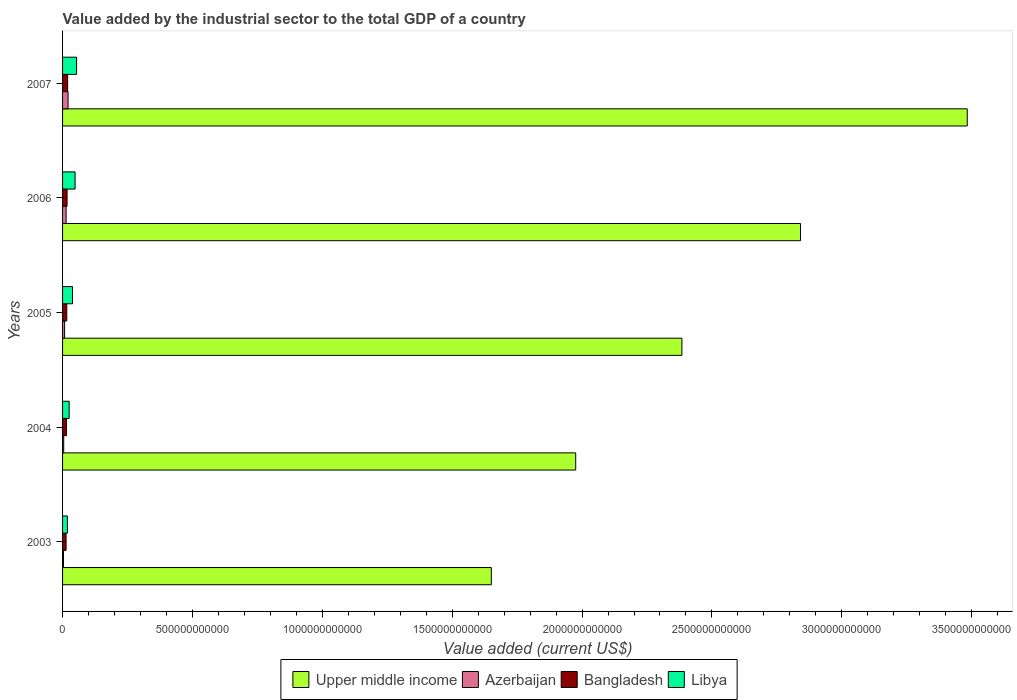How many different coloured bars are there?
Provide a succinct answer. 4. How many groups of bars are there?
Your answer should be very brief. 5. Are the number of bars per tick equal to the number of legend labels?
Offer a terse response. Yes. Are the number of bars on each tick of the Y-axis equal?
Offer a terse response. Yes. How many bars are there on the 2nd tick from the bottom?
Offer a very short reply. 4. In how many cases, is the number of bars for a given year not equal to the number of legend labels?
Your response must be concise. 0. What is the value added by the industrial sector to the total GDP in Azerbaijan in 2004?
Provide a short and direct response. 4.41e+09. Across all years, what is the maximum value added by the industrial sector to the total GDP in Libya?
Your answer should be compact. 5.40e+1. Across all years, what is the minimum value added by the industrial sector to the total GDP in Azerbaijan?
Keep it short and to the point. 3.53e+09. What is the total value added by the industrial sector to the total GDP in Bangladesh in the graph?
Provide a short and direct response. 8.13e+1. What is the difference between the value added by the industrial sector to the total GDP in Libya in 2005 and that in 2007?
Ensure brevity in your answer.  -1.57e+1. What is the difference between the value added by the industrial sector to the total GDP in Bangladesh in 2004 and the value added by the industrial sector to the total GDP in Libya in 2007?
Offer a terse response. -3.92e+1. What is the average value added by the industrial sector to the total GDP in Libya per year?
Give a very brief answer. 3.69e+1. In the year 2003, what is the difference between the value added by the industrial sector to the total GDP in Azerbaijan and value added by the industrial sector to the total GDP in Bangladesh?
Give a very brief answer. -9.99e+09. What is the ratio of the value added by the industrial sector to the total GDP in Upper middle income in 2003 to that in 2005?
Your response must be concise. 0.69. Is the value added by the industrial sector to the total GDP in Upper middle income in 2004 less than that in 2006?
Keep it short and to the point. Yes. What is the difference between the highest and the second highest value added by the industrial sector to the total GDP in Azerbaijan?
Offer a very short reply. 7.51e+09. What is the difference between the highest and the lowest value added by the industrial sector to the total GDP in Azerbaijan?
Provide a short and direct response. 1.76e+1. Is it the case that in every year, the sum of the value added by the industrial sector to the total GDP in Libya and value added by the industrial sector to the total GDP in Bangladesh is greater than the sum of value added by the industrial sector to the total GDP in Azerbaijan and value added by the industrial sector to the total GDP in Upper middle income?
Give a very brief answer. No. What does the 1st bar from the bottom in 2006 represents?
Provide a short and direct response. Upper middle income. Is it the case that in every year, the sum of the value added by the industrial sector to the total GDP in Libya and value added by the industrial sector to the total GDP in Upper middle income is greater than the value added by the industrial sector to the total GDP in Azerbaijan?
Ensure brevity in your answer.  Yes. How many bars are there?
Give a very brief answer. 20. Are all the bars in the graph horizontal?
Ensure brevity in your answer.  Yes. How many years are there in the graph?
Provide a short and direct response. 5. What is the difference between two consecutive major ticks on the X-axis?
Make the answer very short. 5.00e+11. Are the values on the major ticks of X-axis written in scientific E-notation?
Ensure brevity in your answer.  No. Does the graph contain any zero values?
Offer a very short reply. No. Does the graph contain grids?
Give a very brief answer. No. Where does the legend appear in the graph?
Your answer should be very brief. Bottom center. What is the title of the graph?
Provide a short and direct response. Value added by the industrial sector to the total GDP of a country. What is the label or title of the X-axis?
Ensure brevity in your answer.  Value added (current US$). What is the Value added (current US$) in Upper middle income in 2003?
Offer a very short reply. 1.65e+12. What is the Value added (current US$) of Azerbaijan in 2003?
Make the answer very short. 3.53e+09. What is the Value added (current US$) of Bangladesh in 2003?
Keep it short and to the point. 1.35e+1. What is the Value added (current US$) in Libya in 2003?
Provide a succinct answer. 1.86e+1. What is the Value added (current US$) of Upper middle income in 2004?
Provide a short and direct response. 1.98e+12. What is the Value added (current US$) in Azerbaijan in 2004?
Your answer should be compact. 4.41e+09. What is the Value added (current US$) in Bangladesh in 2004?
Provide a short and direct response. 1.48e+1. What is the Value added (current US$) in Libya in 2004?
Offer a very short reply. 2.54e+1. What is the Value added (current US$) in Upper middle income in 2005?
Make the answer very short. 2.38e+12. What is the Value added (current US$) in Azerbaijan in 2005?
Your answer should be compact. 7.79e+09. What is the Value added (current US$) of Bangladesh in 2005?
Offer a very short reply. 1.62e+1. What is the Value added (current US$) of Libya in 2005?
Offer a terse response. 3.83e+1. What is the Value added (current US$) of Upper middle income in 2006?
Offer a terse response. 2.84e+12. What is the Value added (current US$) of Azerbaijan in 2006?
Keep it short and to the point. 1.36e+1. What is the Value added (current US$) of Bangladesh in 2006?
Your answer should be compact. 1.73e+1. What is the Value added (current US$) of Libya in 2006?
Your answer should be very brief. 4.83e+1. What is the Value added (current US$) of Upper middle income in 2007?
Keep it short and to the point. 3.48e+12. What is the Value added (current US$) in Azerbaijan in 2007?
Make the answer very short. 2.11e+1. What is the Value added (current US$) in Bangladesh in 2007?
Your answer should be very brief. 1.95e+1. What is the Value added (current US$) of Libya in 2007?
Your answer should be very brief. 5.40e+1. Across all years, what is the maximum Value added (current US$) of Upper middle income?
Offer a terse response. 3.48e+12. Across all years, what is the maximum Value added (current US$) in Azerbaijan?
Offer a very short reply. 2.11e+1. Across all years, what is the maximum Value added (current US$) in Bangladesh?
Your answer should be very brief. 1.95e+1. Across all years, what is the maximum Value added (current US$) of Libya?
Make the answer very short. 5.40e+1. Across all years, what is the minimum Value added (current US$) of Upper middle income?
Offer a very short reply. 1.65e+12. Across all years, what is the minimum Value added (current US$) of Azerbaijan?
Ensure brevity in your answer.  3.53e+09. Across all years, what is the minimum Value added (current US$) of Bangladesh?
Your response must be concise. 1.35e+1. Across all years, what is the minimum Value added (current US$) of Libya?
Your response must be concise. 1.86e+1. What is the total Value added (current US$) in Upper middle income in the graph?
Provide a succinct answer. 1.23e+13. What is the total Value added (current US$) of Azerbaijan in the graph?
Your answer should be very brief. 5.05e+1. What is the total Value added (current US$) of Bangladesh in the graph?
Give a very brief answer. 8.13e+1. What is the total Value added (current US$) of Libya in the graph?
Make the answer very short. 1.85e+11. What is the difference between the Value added (current US$) in Upper middle income in 2003 and that in 2004?
Your response must be concise. -3.25e+11. What is the difference between the Value added (current US$) of Azerbaijan in 2003 and that in 2004?
Make the answer very short. -8.75e+08. What is the difference between the Value added (current US$) of Bangladesh in 2003 and that in 2004?
Ensure brevity in your answer.  -1.31e+09. What is the difference between the Value added (current US$) in Libya in 2003 and that in 2004?
Offer a terse response. -6.77e+09. What is the difference between the Value added (current US$) of Upper middle income in 2003 and that in 2005?
Your answer should be very brief. -7.34e+11. What is the difference between the Value added (current US$) of Azerbaijan in 2003 and that in 2005?
Keep it short and to the point. -4.26e+09. What is the difference between the Value added (current US$) in Bangladesh in 2003 and that in 2005?
Make the answer very short. -2.66e+09. What is the difference between the Value added (current US$) of Libya in 2003 and that in 2005?
Make the answer very short. -1.97e+1. What is the difference between the Value added (current US$) of Upper middle income in 2003 and that in 2006?
Your answer should be compact. -1.19e+12. What is the difference between the Value added (current US$) of Azerbaijan in 2003 and that in 2006?
Offer a very short reply. -1.01e+1. What is the difference between the Value added (current US$) of Bangladesh in 2003 and that in 2006?
Provide a short and direct response. -3.78e+09. What is the difference between the Value added (current US$) of Libya in 2003 and that in 2006?
Your response must be concise. -2.96e+1. What is the difference between the Value added (current US$) of Upper middle income in 2003 and that in 2007?
Offer a very short reply. -1.83e+12. What is the difference between the Value added (current US$) in Azerbaijan in 2003 and that in 2007?
Give a very brief answer. -1.76e+1. What is the difference between the Value added (current US$) in Bangladesh in 2003 and that in 2007?
Provide a succinct answer. -5.99e+09. What is the difference between the Value added (current US$) in Libya in 2003 and that in 2007?
Your answer should be very brief. -3.54e+1. What is the difference between the Value added (current US$) of Upper middle income in 2004 and that in 2005?
Make the answer very short. -4.09e+11. What is the difference between the Value added (current US$) in Azerbaijan in 2004 and that in 2005?
Your answer should be compact. -3.38e+09. What is the difference between the Value added (current US$) of Bangladesh in 2004 and that in 2005?
Make the answer very short. -1.35e+09. What is the difference between the Value added (current US$) of Libya in 2004 and that in 2005?
Your response must be concise. -1.29e+1. What is the difference between the Value added (current US$) of Upper middle income in 2004 and that in 2006?
Provide a succinct answer. -8.65e+11. What is the difference between the Value added (current US$) in Azerbaijan in 2004 and that in 2006?
Provide a succinct answer. -9.22e+09. What is the difference between the Value added (current US$) in Bangladesh in 2004 and that in 2006?
Provide a succinct answer. -2.47e+09. What is the difference between the Value added (current US$) in Libya in 2004 and that in 2006?
Offer a terse response. -2.29e+1. What is the difference between the Value added (current US$) in Upper middle income in 2004 and that in 2007?
Your response must be concise. -1.51e+12. What is the difference between the Value added (current US$) of Azerbaijan in 2004 and that in 2007?
Your response must be concise. -1.67e+1. What is the difference between the Value added (current US$) in Bangladesh in 2004 and that in 2007?
Your answer should be compact. -4.67e+09. What is the difference between the Value added (current US$) in Libya in 2004 and that in 2007?
Provide a short and direct response. -2.86e+1. What is the difference between the Value added (current US$) in Upper middle income in 2005 and that in 2006?
Ensure brevity in your answer.  -4.57e+11. What is the difference between the Value added (current US$) in Azerbaijan in 2005 and that in 2006?
Make the answer very short. -5.84e+09. What is the difference between the Value added (current US$) in Bangladesh in 2005 and that in 2006?
Give a very brief answer. -1.12e+09. What is the difference between the Value added (current US$) of Libya in 2005 and that in 2006?
Offer a terse response. -9.93e+09. What is the difference between the Value added (current US$) of Upper middle income in 2005 and that in 2007?
Your answer should be compact. -1.10e+12. What is the difference between the Value added (current US$) of Azerbaijan in 2005 and that in 2007?
Offer a terse response. -1.34e+1. What is the difference between the Value added (current US$) of Bangladesh in 2005 and that in 2007?
Provide a succinct answer. -3.33e+09. What is the difference between the Value added (current US$) of Libya in 2005 and that in 2007?
Provide a succinct answer. -1.57e+1. What is the difference between the Value added (current US$) in Upper middle income in 2006 and that in 2007?
Make the answer very short. -6.42e+11. What is the difference between the Value added (current US$) of Azerbaijan in 2006 and that in 2007?
Make the answer very short. -7.51e+09. What is the difference between the Value added (current US$) in Bangladesh in 2006 and that in 2007?
Offer a very short reply. -2.20e+09. What is the difference between the Value added (current US$) of Libya in 2006 and that in 2007?
Give a very brief answer. -5.77e+09. What is the difference between the Value added (current US$) of Upper middle income in 2003 and the Value added (current US$) of Azerbaijan in 2004?
Give a very brief answer. 1.65e+12. What is the difference between the Value added (current US$) in Upper middle income in 2003 and the Value added (current US$) in Bangladesh in 2004?
Give a very brief answer. 1.64e+12. What is the difference between the Value added (current US$) of Upper middle income in 2003 and the Value added (current US$) of Libya in 2004?
Provide a short and direct response. 1.63e+12. What is the difference between the Value added (current US$) in Azerbaijan in 2003 and the Value added (current US$) in Bangladesh in 2004?
Make the answer very short. -1.13e+1. What is the difference between the Value added (current US$) in Azerbaijan in 2003 and the Value added (current US$) in Libya in 2004?
Your response must be concise. -2.19e+1. What is the difference between the Value added (current US$) of Bangladesh in 2003 and the Value added (current US$) of Libya in 2004?
Keep it short and to the point. -1.19e+1. What is the difference between the Value added (current US$) of Upper middle income in 2003 and the Value added (current US$) of Azerbaijan in 2005?
Your answer should be compact. 1.64e+12. What is the difference between the Value added (current US$) of Upper middle income in 2003 and the Value added (current US$) of Bangladesh in 2005?
Give a very brief answer. 1.63e+12. What is the difference between the Value added (current US$) of Upper middle income in 2003 and the Value added (current US$) of Libya in 2005?
Provide a short and direct response. 1.61e+12. What is the difference between the Value added (current US$) of Azerbaijan in 2003 and the Value added (current US$) of Bangladesh in 2005?
Your answer should be very brief. -1.26e+1. What is the difference between the Value added (current US$) of Azerbaijan in 2003 and the Value added (current US$) of Libya in 2005?
Provide a short and direct response. -3.48e+1. What is the difference between the Value added (current US$) in Bangladesh in 2003 and the Value added (current US$) in Libya in 2005?
Provide a short and direct response. -2.48e+1. What is the difference between the Value added (current US$) of Upper middle income in 2003 and the Value added (current US$) of Azerbaijan in 2006?
Offer a terse response. 1.64e+12. What is the difference between the Value added (current US$) in Upper middle income in 2003 and the Value added (current US$) in Bangladesh in 2006?
Provide a succinct answer. 1.63e+12. What is the difference between the Value added (current US$) in Upper middle income in 2003 and the Value added (current US$) in Libya in 2006?
Your response must be concise. 1.60e+12. What is the difference between the Value added (current US$) in Azerbaijan in 2003 and the Value added (current US$) in Bangladesh in 2006?
Your answer should be compact. -1.38e+1. What is the difference between the Value added (current US$) in Azerbaijan in 2003 and the Value added (current US$) in Libya in 2006?
Provide a succinct answer. -4.47e+1. What is the difference between the Value added (current US$) of Bangladesh in 2003 and the Value added (current US$) of Libya in 2006?
Provide a succinct answer. -3.47e+1. What is the difference between the Value added (current US$) of Upper middle income in 2003 and the Value added (current US$) of Azerbaijan in 2007?
Provide a succinct answer. 1.63e+12. What is the difference between the Value added (current US$) in Upper middle income in 2003 and the Value added (current US$) in Bangladesh in 2007?
Offer a very short reply. 1.63e+12. What is the difference between the Value added (current US$) of Upper middle income in 2003 and the Value added (current US$) of Libya in 2007?
Your answer should be very brief. 1.60e+12. What is the difference between the Value added (current US$) of Azerbaijan in 2003 and the Value added (current US$) of Bangladesh in 2007?
Ensure brevity in your answer.  -1.60e+1. What is the difference between the Value added (current US$) in Azerbaijan in 2003 and the Value added (current US$) in Libya in 2007?
Provide a short and direct response. -5.05e+1. What is the difference between the Value added (current US$) of Bangladesh in 2003 and the Value added (current US$) of Libya in 2007?
Ensure brevity in your answer.  -4.05e+1. What is the difference between the Value added (current US$) in Upper middle income in 2004 and the Value added (current US$) in Azerbaijan in 2005?
Offer a very short reply. 1.97e+12. What is the difference between the Value added (current US$) in Upper middle income in 2004 and the Value added (current US$) in Bangladesh in 2005?
Provide a short and direct response. 1.96e+12. What is the difference between the Value added (current US$) of Upper middle income in 2004 and the Value added (current US$) of Libya in 2005?
Provide a short and direct response. 1.94e+12. What is the difference between the Value added (current US$) in Azerbaijan in 2004 and the Value added (current US$) in Bangladesh in 2005?
Keep it short and to the point. -1.18e+1. What is the difference between the Value added (current US$) in Azerbaijan in 2004 and the Value added (current US$) in Libya in 2005?
Make the answer very short. -3.39e+1. What is the difference between the Value added (current US$) in Bangladesh in 2004 and the Value added (current US$) in Libya in 2005?
Offer a very short reply. -2.35e+1. What is the difference between the Value added (current US$) in Upper middle income in 2004 and the Value added (current US$) in Azerbaijan in 2006?
Provide a short and direct response. 1.96e+12. What is the difference between the Value added (current US$) of Upper middle income in 2004 and the Value added (current US$) of Bangladesh in 2006?
Make the answer very short. 1.96e+12. What is the difference between the Value added (current US$) in Upper middle income in 2004 and the Value added (current US$) in Libya in 2006?
Keep it short and to the point. 1.93e+12. What is the difference between the Value added (current US$) in Azerbaijan in 2004 and the Value added (current US$) in Bangladesh in 2006?
Offer a terse response. -1.29e+1. What is the difference between the Value added (current US$) of Azerbaijan in 2004 and the Value added (current US$) of Libya in 2006?
Ensure brevity in your answer.  -4.38e+1. What is the difference between the Value added (current US$) of Bangladesh in 2004 and the Value added (current US$) of Libya in 2006?
Offer a very short reply. -3.34e+1. What is the difference between the Value added (current US$) of Upper middle income in 2004 and the Value added (current US$) of Azerbaijan in 2007?
Give a very brief answer. 1.95e+12. What is the difference between the Value added (current US$) in Upper middle income in 2004 and the Value added (current US$) in Bangladesh in 2007?
Give a very brief answer. 1.96e+12. What is the difference between the Value added (current US$) of Upper middle income in 2004 and the Value added (current US$) of Libya in 2007?
Offer a terse response. 1.92e+12. What is the difference between the Value added (current US$) of Azerbaijan in 2004 and the Value added (current US$) of Bangladesh in 2007?
Provide a succinct answer. -1.51e+1. What is the difference between the Value added (current US$) in Azerbaijan in 2004 and the Value added (current US$) in Libya in 2007?
Your response must be concise. -4.96e+1. What is the difference between the Value added (current US$) of Bangladesh in 2004 and the Value added (current US$) of Libya in 2007?
Give a very brief answer. -3.92e+1. What is the difference between the Value added (current US$) in Upper middle income in 2005 and the Value added (current US$) in Azerbaijan in 2006?
Ensure brevity in your answer.  2.37e+12. What is the difference between the Value added (current US$) in Upper middle income in 2005 and the Value added (current US$) in Bangladesh in 2006?
Ensure brevity in your answer.  2.37e+12. What is the difference between the Value added (current US$) of Upper middle income in 2005 and the Value added (current US$) of Libya in 2006?
Offer a terse response. 2.34e+12. What is the difference between the Value added (current US$) of Azerbaijan in 2005 and the Value added (current US$) of Bangladesh in 2006?
Ensure brevity in your answer.  -9.52e+09. What is the difference between the Value added (current US$) in Azerbaijan in 2005 and the Value added (current US$) in Libya in 2006?
Keep it short and to the point. -4.05e+1. What is the difference between the Value added (current US$) in Bangladesh in 2005 and the Value added (current US$) in Libya in 2006?
Make the answer very short. -3.21e+1. What is the difference between the Value added (current US$) in Upper middle income in 2005 and the Value added (current US$) in Azerbaijan in 2007?
Your answer should be very brief. 2.36e+12. What is the difference between the Value added (current US$) in Upper middle income in 2005 and the Value added (current US$) in Bangladesh in 2007?
Provide a short and direct response. 2.36e+12. What is the difference between the Value added (current US$) in Upper middle income in 2005 and the Value added (current US$) in Libya in 2007?
Keep it short and to the point. 2.33e+12. What is the difference between the Value added (current US$) in Azerbaijan in 2005 and the Value added (current US$) in Bangladesh in 2007?
Ensure brevity in your answer.  -1.17e+1. What is the difference between the Value added (current US$) of Azerbaijan in 2005 and the Value added (current US$) of Libya in 2007?
Make the answer very short. -4.62e+1. What is the difference between the Value added (current US$) in Bangladesh in 2005 and the Value added (current US$) in Libya in 2007?
Provide a succinct answer. -3.78e+1. What is the difference between the Value added (current US$) in Upper middle income in 2006 and the Value added (current US$) in Azerbaijan in 2007?
Your response must be concise. 2.82e+12. What is the difference between the Value added (current US$) of Upper middle income in 2006 and the Value added (current US$) of Bangladesh in 2007?
Provide a succinct answer. 2.82e+12. What is the difference between the Value added (current US$) of Upper middle income in 2006 and the Value added (current US$) of Libya in 2007?
Your response must be concise. 2.79e+12. What is the difference between the Value added (current US$) of Azerbaijan in 2006 and the Value added (current US$) of Bangladesh in 2007?
Ensure brevity in your answer.  -5.88e+09. What is the difference between the Value added (current US$) of Azerbaijan in 2006 and the Value added (current US$) of Libya in 2007?
Ensure brevity in your answer.  -4.04e+1. What is the difference between the Value added (current US$) in Bangladesh in 2006 and the Value added (current US$) in Libya in 2007?
Provide a short and direct response. -3.67e+1. What is the average Value added (current US$) of Upper middle income per year?
Keep it short and to the point. 2.47e+12. What is the average Value added (current US$) of Azerbaijan per year?
Your response must be concise. 1.01e+1. What is the average Value added (current US$) of Bangladesh per year?
Your answer should be very brief. 1.63e+1. What is the average Value added (current US$) of Libya per year?
Your answer should be very brief. 3.69e+1. In the year 2003, what is the difference between the Value added (current US$) in Upper middle income and Value added (current US$) in Azerbaijan?
Your answer should be very brief. 1.65e+12. In the year 2003, what is the difference between the Value added (current US$) in Upper middle income and Value added (current US$) in Bangladesh?
Your response must be concise. 1.64e+12. In the year 2003, what is the difference between the Value added (current US$) in Upper middle income and Value added (current US$) in Libya?
Make the answer very short. 1.63e+12. In the year 2003, what is the difference between the Value added (current US$) in Azerbaijan and Value added (current US$) in Bangladesh?
Keep it short and to the point. -9.99e+09. In the year 2003, what is the difference between the Value added (current US$) of Azerbaijan and Value added (current US$) of Libya?
Offer a terse response. -1.51e+1. In the year 2003, what is the difference between the Value added (current US$) of Bangladesh and Value added (current US$) of Libya?
Your response must be concise. -5.10e+09. In the year 2004, what is the difference between the Value added (current US$) in Upper middle income and Value added (current US$) in Azerbaijan?
Keep it short and to the point. 1.97e+12. In the year 2004, what is the difference between the Value added (current US$) in Upper middle income and Value added (current US$) in Bangladesh?
Keep it short and to the point. 1.96e+12. In the year 2004, what is the difference between the Value added (current US$) in Upper middle income and Value added (current US$) in Libya?
Keep it short and to the point. 1.95e+12. In the year 2004, what is the difference between the Value added (current US$) in Azerbaijan and Value added (current US$) in Bangladesh?
Your answer should be compact. -1.04e+1. In the year 2004, what is the difference between the Value added (current US$) in Azerbaijan and Value added (current US$) in Libya?
Ensure brevity in your answer.  -2.10e+1. In the year 2004, what is the difference between the Value added (current US$) in Bangladesh and Value added (current US$) in Libya?
Your answer should be very brief. -1.06e+1. In the year 2005, what is the difference between the Value added (current US$) in Upper middle income and Value added (current US$) in Azerbaijan?
Your response must be concise. 2.38e+12. In the year 2005, what is the difference between the Value added (current US$) in Upper middle income and Value added (current US$) in Bangladesh?
Your answer should be compact. 2.37e+12. In the year 2005, what is the difference between the Value added (current US$) of Upper middle income and Value added (current US$) of Libya?
Your answer should be very brief. 2.35e+12. In the year 2005, what is the difference between the Value added (current US$) in Azerbaijan and Value added (current US$) in Bangladesh?
Provide a succinct answer. -8.39e+09. In the year 2005, what is the difference between the Value added (current US$) in Azerbaijan and Value added (current US$) in Libya?
Ensure brevity in your answer.  -3.05e+1. In the year 2005, what is the difference between the Value added (current US$) of Bangladesh and Value added (current US$) of Libya?
Give a very brief answer. -2.21e+1. In the year 2006, what is the difference between the Value added (current US$) in Upper middle income and Value added (current US$) in Azerbaijan?
Your response must be concise. 2.83e+12. In the year 2006, what is the difference between the Value added (current US$) of Upper middle income and Value added (current US$) of Bangladesh?
Provide a short and direct response. 2.82e+12. In the year 2006, what is the difference between the Value added (current US$) of Upper middle income and Value added (current US$) of Libya?
Ensure brevity in your answer.  2.79e+12. In the year 2006, what is the difference between the Value added (current US$) of Azerbaijan and Value added (current US$) of Bangladesh?
Offer a very short reply. -3.67e+09. In the year 2006, what is the difference between the Value added (current US$) in Azerbaijan and Value added (current US$) in Libya?
Make the answer very short. -3.46e+1. In the year 2006, what is the difference between the Value added (current US$) of Bangladesh and Value added (current US$) of Libya?
Provide a succinct answer. -3.09e+1. In the year 2007, what is the difference between the Value added (current US$) in Upper middle income and Value added (current US$) in Azerbaijan?
Ensure brevity in your answer.  3.46e+12. In the year 2007, what is the difference between the Value added (current US$) in Upper middle income and Value added (current US$) in Bangladesh?
Provide a succinct answer. 3.46e+12. In the year 2007, what is the difference between the Value added (current US$) in Upper middle income and Value added (current US$) in Libya?
Your response must be concise. 3.43e+12. In the year 2007, what is the difference between the Value added (current US$) of Azerbaijan and Value added (current US$) of Bangladesh?
Keep it short and to the point. 1.64e+09. In the year 2007, what is the difference between the Value added (current US$) in Azerbaijan and Value added (current US$) in Libya?
Ensure brevity in your answer.  -3.29e+1. In the year 2007, what is the difference between the Value added (current US$) in Bangladesh and Value added (current US$) in Libya?
Your answer should be compact. -3.45e+1. What is the ratio of the Value added (current US$) in Upper middle income in 2003 to that in 2004?
Provide a short and direct response. 0.84. What is the ratio of the Value added (current US$) of Azerbaijan in 2003 to that in 2004?
Make the answer very short. 0.8. What is the ratio of the Value added (current US$) in Bangladesh in 2003 to that in 2004?
Offer a terse response. 0.91. What is the ratio of the Value added (current US$) of Libya in 2003 to that in 2004?
Keep it short and to the point. 0.73. What is the ratio of the Value added (current US$) of Upper middle income in 2003 to that in 2005?
Ensure brevity in your answer.  0.69. What is the ratio of the Value added (current US$) of Azerbaijan in 2003 to that in 2005?
Make the answer very short. 0.45. What is the ratio of the Value added (current US$) of Bangladesh in 2003 to that in 2005?
Ensure brevity in your answer.  0.84. What is the ratio of the Value added (current US$) in Libya in 2003 to that in 2005?
Offer a very short reply. 0.49. What is the ratio of the Value added (current US$) in Upper middle income in 2003 to that in 2006?
Offer a terse response. 0.58. What is the ratio of the Value added (current US$) of Azerbaijan in 2003 to that in 2006?
Give a very brief answer. 0.26. What is the ratio of the Value added (current US$) of Bangladesh in 2003 to that in 2006?
Make the answer very short. 0.78. What is the ratio of the Value added (current US$) of Libya in 2003 to that in 2006?
Provide a short and direct response. 0.39. What is the ratio of the Value added (current US$) in Upper middle income in 2003 to that in 2007?
Make the answer very short. 0.47. What is the ratio of the Value added (current US$) of Azerbaijan in 2003 to that in 2007?
Give a very brief answer. 0.17. What is the ratio of the Value added (current US$) in Bangladesh in 2003 to that in 2007?
Provide a short and direct response. 0.69. What is the ratio of the Value added (current US$) in Libya in 2003 to that in 2007?
Keep it short and to the point. 0.34. What is the ratio of the Value added (current US$) of Upper middle income in 2004 to that in 2005?
Give a very brief answer. 0.83. What is the ratio of the Value added (current US$) of Azerbaijan in 2004 to that in 2005?
Give a very brief answer. 0.57. What is the ratio of the Value added (current US$) of Bangladesh in 2004 to that in 2005?
Your response must be concise. 0.92. What is the ratio of the Value added (current US$) of Libya in 2004 to that in 2005?
Make the answer very short. 0.66. What is the ratio of the Value added (current US$) of Upper middle income in 2004 to that in 2006?
Your response must be concise. 0.7. What is the ratio of the Value added (current US$) in Azerbaijan in 2004 to that in 2006?
Give a very brief answer. 0.32. What is the ratio of the Value added (current US$) of Libya in 2004 to that in 2006?
Offer a terse response. 0.53. What is the ratio of the Value added (current US$) in Upper middle income in 2004 to that in 2007?
Provide a succinct answer. 0.57. What is the ratio of the Value added (current US$) in Azerbaijan in 2004 to that in 2007?
Keep it short and to the point. 0.21. What is the ratio of the Value added (current US$) of Bangladesh in 2004 to that in 2007?
Offer a terse response. 0.76. What is the ratio of the Value added (current US$) in Libya in 2004 to that in 2007?
Your answer should be very brief. 0.47. What is the ratio of the Value added (current US$) of Upper middle income in 2005 to that in 2006?
Your answer should be compact. 0.84. What is the ratio of the Value added (current US$) of Azerbaijan in 2005 to that in 2006?
Keep it short and to the point. 0.57. What is the ratio of the Value added (current US$) of Bangladesh in 2005 to that in 2006?
Provide a short and direct response. 0.94. What is the ratio of the Value added (current US$) of Libya in 2005 to that in 2006?
Your answer should be very brief. 0.79. What is the ratio of the Value added (current US$) in Upper middle income in 2005 to that in 2007?
Your answer should be compact. 0.68. What is the ratio of the Value added (current US$) in Azerbaijan in 2005 to that in 2007?
Provide a short and direct response. 0.37. What is the ratio of the Value added (current US$) in Bangladesh in 2005 to that in 2007?
Offer a very short reply. 0.83. What is the ratio of the Value added (current US$) of Libya in 2005 to that in 2007?
Your answer should be very brief. 0.71. What is the ratio of the Value added (current US$) of Upper middle income in 2006 to that in 2007?
Ensure brevity in your answer.  0.82. What is the ratio of the Value added (current US$) in Azerbaijan in 2006 to that in 2007?
Offer a very short reply. 0.64. What is the ratio of the Value added (current US$) in Bangladesh in 2006 to that in 2007?
Your answer should be very brief. 0.89. What is the ratio of the Value added (current US$) in Libya in 2006 to that in 2007?
Your answer should be compact. 0.89. What is the difference between the highest and the second highest Value added (current US$) of Upper middle income?
Give a very brief answer. 6.42e+11. What is the difference between the highest and the second highest Value added (current US$) in Azerbaijan?
Offer a very short reply. 7.51e+09. What is the difference between the highest and the second highest Value added (current US$) of Bangladesh?
Ensure brevity in your answer.  2.20e+09. What is the difference between the highest and the second highest Value added (current US$) in Libya?
Give a very brief answer. 5.77e+09. What is the difference between the highest and the lowest Value added (current US$) in Upper middle income?
Your answer should be compact. 1.83e+12. What is the difference between the highest and the lowest Value added (current US$) of Azerbaijan?
Give a very brief answer. 1.76e+1. What is the difference between the highest and the lowest Value added (current US$) in Bangladesh?
Your answer should be compact. 5.99e+09. What is the difference between the highest and the lowest Value added (current US$) in Libya?
Give a very brief answer. 3.54e+1. 